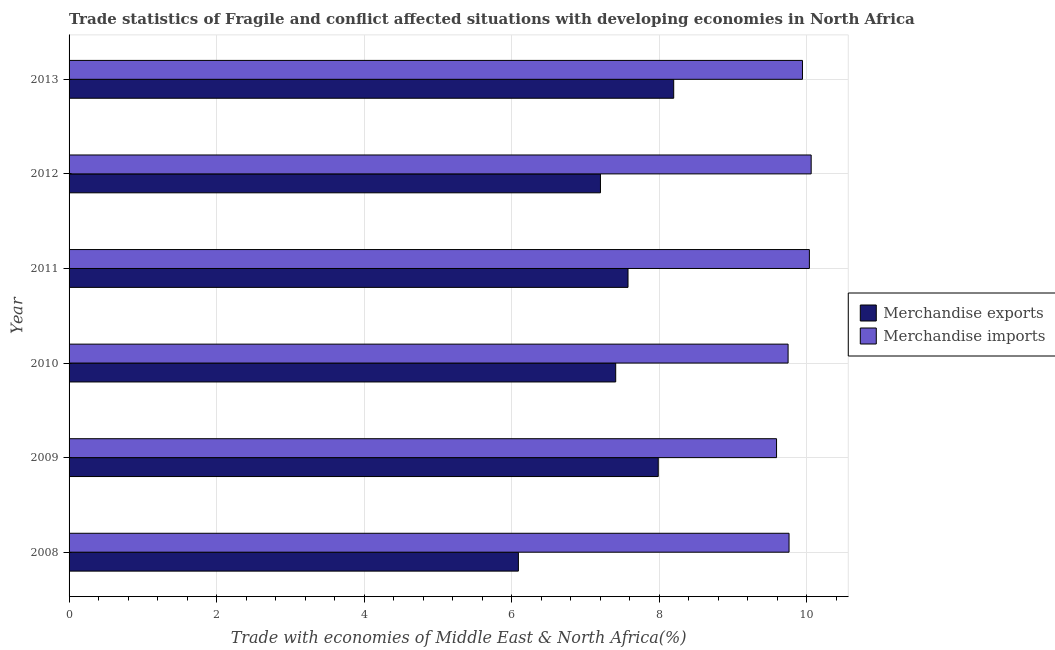How many different coloured bars are there?
Ensure brevity in your answer.  2. How many groups of bars are there?
Provide a succinct answer. 6. Are the number of bars per tick equal to the number of legend labels?
Give a very brief answer. Yes. How many bars are there on the 5th tick from the bottom?
Provide a succinct answer. 2. What is the label of the 2nd group of bars from the top?
Your answer should be very brief. 2012. In how many cases, is the number of bars for a given year not equal to the number of legend labels?
Your answer should be compact. 0. What is the merchandise imports in 2011?
Your answer should be very brief. 10.04. Across all years, what is the maximum merchandise imports?
Your response must be concise. 10.06. Across all years, what is the minimum merchandise exports?
Provide a succinct answer. 6.09. In which year was the merchandise imports maximum?
Provide a succinct answer. 2012. What is the total merchandise imports in the graph?
Give a very brief answer. 59.15. What is the difference between the merchandise imports in 2008 and that in 2011?
Offer a terse response. -0.28. What is the difference between the merchandise imports in 2009 and the merchandise exports in 2013?
Ensure brevity in your answer.  1.39. What is the average merchandise exports per year?
Your answer should be very brief. 7.41. In the year 2009, what is the difference between the merchandise imports and merchandise exports?
Ensure brevity in your answer.  1.6. What is the ratio of the merchandise exports in 2009 to that in 2012?
Offer a very short reply. 1.11. Is the merchandise exports in 2008 less than that in 2009?
Keep it short and to the point. Yes. Is the difference between the merchandise exports in 2008 and 2012 greater than the difference between the merchandise imports in 2008 and 2012?
Your response must be concise. No. What is the difference between the highest and the second highest merchandise imports?
Your response must be concise. 0.02. What is the difference between the highest and the lowest merchandise imports?
Give a very brief answer. 0.47. What does the 2nd bar from the top in 2008 represents?
Ensure brevity in your answer.  Merchandise exports. What does the 2nd bar from the bottom in 2012 represents?
Give a very brief answer. Merchandise imports. Are all the bars in the graph horizontal?
Make the answer very short. Yes. How many years are there in the graph?
Keep it short and to the point. 6. What is the difference between two consecutive major ticks on the X-axis?
Keep it short and to the point. 2. Are the values on the major ticks of X-axis written in scientific E-notation?
Your answer should be compact. No. Does the graph contain any zero values?
Give a very brief answer. No. Does the graph contain grids?
Ensure brevity in your answer.  Yes. How many legend labels are there?
Provide a succinct answer. 2. What is the title of the graph?
Your answer should be very brief. Trade statistics of Fragile and conflict affected situations with developing economies in North Africa. What is the label or title of the X-axis?
Ensure brevity in your answer.  Trade with economies of Middle East & North Africa(%). What is the Trade with economies of Middle East & North Africa(%) in Merchandise exports in 2008?
Give a very brief answer. 6.09. What is the Trade with economies of Middle East & North Africa(%) of Merchandise imports in 2008?
Your answer should be compact. 9.76. What is the Trade with economies of Middle East & North Africa(%) of Merchandise exports in 2009?
Offer a terse response. 7.99. What is the Trade with economies of Middle East & North Africa(%) in Merchandise imports in 2009?
Provide a short and direct response. 9.59. What is the Trade with economies of Middle East & North Africa(%) in Merchandise exports in 2010?
Keep it short and to the point. 7.41. What is the Trade with economies of Middle East & North Africa(%) in Merchandise imports in 2010?
Provide a short and direct response. 9.75. What is the Trade with economies of Middle East & North Africa(%) of Merchandise exports in 2011?
Provide a short and direct response. 7.58. What is the Trade with economies of Middle East & North Africa(%) of Merchandise imports in 2011?
Your response must be concise. 10.04. What is the Trade with economies of Middle East & North Africa(%) in Merchandise exports in 2012?
Make the answer very short. 7.21. What is the Trade with economies of Middle East & North Africa(%) of Merchandise imports in 2012?
Provide a succinct answer. 10.06. What is the Trade with economies of Middle East & North Africa(%) of Merchandise exports in 2013?
Provide a succinct answer. 8.2. What is the Trade with economies of Middle East & North Africa(%) in Merchandise imports in 2013?
Keep it short and to the point. 9.95. Across all years, what is the maximum Trade with economies of Middle East & North Africa(%) in Merchandise exports?
Provide a short and direct response. 8.2. Across all years, what is the maximum Trade with economies of Middle East & North Africa(%) in Merchandise imports?
Your answer should be very brief. 10.06. Across all years, what is the minimum Trade with economies of Middle East & North Africa(%) in Merchandise exports?
Offer a very short reply. 6.09. Across all years, what is the minimum Trade with economies of Middle East & North Africa(%) in Merchandise imports?
Ensure brevity in your answer.  9.59. What is the total Trade with economies of Middle East & North Africa(%) in Merchandise exports in the graph?
Offer a terse response. 44.48. What is the total Trade with economies of Middle East & North Africa(%) of Merchandise imports in the graph?
Offer a very short reply. 59.15. What is the difference between the Trade with economies of Middle East & North Africa(%) of Merchandise exports in 2008 and that in 2009?
Offer a terse response. -1.9. What is the difference between the Trade with economies of Middle East & North Africa(%) in Merchandise imports in 2008 and that in 2009?
Provide a short and direct response. 0.17. What is the difference between the Trade with economies of Middle East & North Africa(%) in Merchandise exports in 2008 and that in 2010?
Make the answer very short. -1.32. What is the difference between the Trade with economies of Middle East & North Africa(%) of Merchandise imports in 2008 and that in 2010?
Offer a very short reply. 0.01. What is the difference between the Trade with economies of Middle East & North Africa(%) in Merchandise exports in 2008 and that in 2011?
Your response must be concise. -1.49. What is the difference between the Trade with economies of Middle East & North Africa(%) in Merchandise imports in 2008 and that in 2011?
Offer a terse response. -0.28. What is the difference between the Trade with economies of Middle East & North Africa(%) of Merchandise exports in 2008 and that in 2012?
Give a very brief answer. -1.11. What is the difference between the Trade with economies of Middle East & North Africa(%) of Merchandise exports in 2008 and that in 2013?
Make the answer very short. -2.11. What is the difference between the Trade with economies of Middle East & North Africa(%) of Merchandise imports in 2008 and that in 2013?
Offer a terse response. -0.18. What is the difference between the Trade with economies of Middle East & North Africa(%) of Merchandise exports in 2009 and that in 2010?
Keep it short and to the point. 0.58. What is the difference between the Trade with economies of Middle East & North Africa(%) in Merchandise imports in 2009 and that in 2010?
Keep it short and to the point. -0.16. What is the difference between the Trade with economies of Middle East & North Africa(%) in Merchandise exports in 2009 and that in 2011?
Ensure brevity in your answer.  0.41. What is the difference between the Trade with economies of Middle East & North Africa(%) of Merchandise imports in 2009 and that in 2011?
Offer a terse response. -0.45. What is the difference between the Trade with economies of Middle East & North Africa(%) in Merchandise exports in 2009 and that in 2012?
Offer a terse response. 0.78. What is the difference between the Trade with economies of Middle East & North Africa(%) in Merchandise imports in 2009 and that in 2012?
Your response must be concise. -0.47. What is the difference between the Trade with economies of Middle East & North Africa(%) in Merchandise exports in 2009 and that in 2013?
Offer a very short reply. -0.21. What is the difference between the Trade with economies of Middle East & North Africa(%) of Merchandise imports in 2009 and that in 2013?
Your response must be concise. -0.35. What is the difference between the Trade with economies of Middle East & North Africa(%) of Merchandise exports in 2010 and that in 2011?
Ensure brevity in your answer.  -0.17. What is the difference between the Trade with economies of Middle East & North Africa(%) of Merchandise imports in 2010 and that in 2011?
Your answer should be compact. -0.29. What is the difference between the Trade with economies of Middle East & North Africa(%) of Merchandise exports in 2010 and that in 2012?
Give a very brief answer. 0.21. What is the difference between the Trade with economies of Middle East & North Africa(%) of Merchandise imports in 2010 and that in 2012?
Ensure brevity in your answer.  -0.31. What is the difference between the Trade with economies of Middle East & North Africa(%) of Merchandise exports in 2010 and that in 2013?
Your answer should be very brief. -0.79. What is the difference between the Trade with economies of Middle East & North Africa(%) in Merchandise imports in 2010 and that in 2013?
Keep it short and to the point. -0.2. What is the difference between the Trade with economies of Middle East & North Africa(%) of Merchandise exports in 2011 and that in 2012?
Your response must be concise. 0.37. What is the difference between the Trade with economies of Middle East & North Africa(%) in Merchandise imports in 2011 and that in 2012?
Make the answer very short. -0.02. What is the difference between the Trade with economies of Middle East & North Africa(%) in Merchandise exports in 2011 and that in 2013?
Your answer should be very brief. -0.62. What is the difference between the Trade with economies of Middle East & North Africa(%) in Merchandise imports in 2011 and that in 2013?
Give a very brief answer. 0.09. What is the difference between the Trade with economies of Middle East & North Africa(%) of Merchandise exports in 2012 and that in 2013?
Make the answer very short. -0.99. What is the difference between the Trade with economies of Middle East & North Africa(%) of Merchandise imports in 2012 and that in 2013?
Give a very brief answer. 0.12. What is the difference between the Trade with economies of Middle East & North Africa(%) in Merchandise exports in 2008 and the Trade with economies of Middle East & North Africa(%) in Merchandise imports in 2009?
Make the answer very short. -3.5. What is the difference between the Trade with economies of Middle East & North Africa(%) of Merchandise exports in 2008 and the Trade with economies of Middle East & North Africa(%) of Merchandise imports in 2010?
Your answer should be very brief. -3.66. What is the difference between the Trade with economies of Middle East & North Africa(%) of Merchandise exports in 2008 and the Trade with economies of Middle East & North Africa(%) of Merchandise imports in 2011?
Provide a short and direct response. -3.95. What is the difference between the Trade with economies of Middle East & North Africa(%) of Merchandise exports in 2008 and the Trade with economies of Middle East & North Africa(%) of Merchandise imports in 2012?
Ensure brevity in your answer.  -3.97. What is the difference between the Trade with economies of Middle East & North Africa(%) in Merchandise exports in 2008 and the Trade with economies of Middle East & North Africa(%) in Merchandise imports in 2013?
Your response must be concise. -3.85. What is the difference between the Trade with economies of Middle East & North Africa(%) in Merchandise exports in 2009 and the Trade with economies of Middle East & North Africa(%) in Merchandise imports in 2010?
Offer a terse response. -1.76. What is the difference between the Trade with economies of Middle East & North Africa(%) of Merchandise exports in 2009 and the Trade with economies of Middle East & North Africa(%) of Merchandise imports in 2011?
Give a very brief answer. -2.05. What is the difference between the Trade with economies of Middle East & North Africa(%) of Merchandise exports in 2009 and the Trade with economies of Middle East & North Africa(%) of Merchandise imports in 2012?
Give a very brief answer. -2.07. What is the difference between the Trade with economies of Middle East & North Africa(%) in Merchandise exports in 2009 and the Trade with economies of Middle East & North Africa(%) in Merchandise imports in 2013?
Offer a terse response. -1.96. What is the difference between the Trade with economies of Middle East & North Africa(%) of Merchandise exports in 2010 and the Trade with economies of Middle East & North Africa(%) of Merchandise imports in 2011?
Provide a succinct answer. -2.63. What is the difference between the Trade with economies of Middle East & North Africa(%) of Merchandise exports in 2010 and the Trade with economies of Middle East & North Africa(%) of Merchandise imports in 2012?
Offer a terse response. -2.65. What is the difference between the Trade with economies of Middle East & North Africa(%) of Merchandise exports in 2010 and the Trade with economies of Middle East & North Africa(%) of Merchandise imports in 2013?
Offer a terse response. -2.53. What is the difference between the Trade with economies of Middle East & North Africa(%) of Merchandise exports in 2011 and the Trade with economies of Middle East & North Africa(%) of Merchandise imports in 2012?
Make the answer very short. -2.48. What is the difference between the Trade with economies of Middle East & North Africa(%) in Merchandise exports in 2011 and the Trade with economies of Middle East & North Africa(%) in Merchandise imports in 2013?
Ensure brevity in your answer.  -2.37. What is the difference between the Trade with economies of Middle East & North Africa(%) of Merchandise exports in 2012 and the Trade with economies of Middle East & North Africa(%) of Merchandise imports in 2013?
Offer a very short reply. -2.74. What is the average Trade with economies of Middle East & North Africa(%) of Merchandise exports per year?
Keep it short and to the point. 7.41. What is the average Trade with economies of Middle East & North Africa(%) in Merchandise imports per year?
Provide a short and direct response. 9.86. In the year 2008, what is the difference between the Trade with economies of Middle East & North Africa(%) of Merchandise exports and Trade with economies of Middle East & North Africa(%) of Merchandise imports?
Provide a succinct answer. -3.67. In the year 2009, what is the difference between the Trade with economies of Middle East & North Africa(%) in Merchandise exports and Trade with economies of Middle East & North Africa(%) in Merchandise imports?
Ensure brevity in your answer.  -1.6. In the year 2010, what is the difference between the Trade with economies of Middle East & North Africa(%) in Merchandise exports and Trade with economies of Middle East & North Africa(%) in Merchandise imports?
Give a very brief answer. -2.34. In the year 2011, what is the difference between the Trade with economies of Middle East & North Africa(%) in Merchandise exports and Trade with economies of Middle East & North Africa(%) in Merchandise imports?
Your answer should be compact. -2.46. In the year 2012, what is the difference between the Trade with economies of Middle East & North Africa(%) of Merchandise exports and Trade with economies of Middle East & North Africa(%) of Merchandise imports?
Provide a short and direct response. -2.86. In the year 2013, what is the difference between the Trade with economies of Middle East & North Africa(%) in Merchandise exports and Trade with economies of Middle East & North Africa(%) in Merchandise imports?
Keep it short and to the point. -1.75. What is the ratio of the Trade with economies of Middle East & North Africa(%) of Merchandise exports in 2008 to that in 2009?
Provide a short and direct response. 0.76. What is the ratio of the Trade with economies of Middle East & North Africa(%) in Merchandise imports in 2008 to that in 2009?
Your response must be concise. 1.02. What is the ratio of the Trade with economies of Middle East & North Africa(%) in Merchandise exports in 2008 to that in 2010?
Give a very brief answer. 0.82. What is the ratio of the Trade with economies of Middle East & North Africa(%) of Merchandise exports in 2008 to that in 2011?
Your answer should be very brief. 0.8. What is the ratio of the Trade with economies of Middle East & North Africa(%) in Merchandise imports in 2008 to that in 2011?
Ensure brevity in your answer.  0.97. What is the ratio of the Trade with economies of Middle East & North Africa(%) of Merchandise exports in 2008 to that in 2012?
Provide a short and direct response. 0.85. What is the ratio of the Trade with economies of Middle East & North Africa(%) of Merchandise imports in 2008 to that in 2012?
Give a very brief answer. 0.97. What is the ratio of the Trade with economies of Middle East & North Africa(%) of Merchandise exports in 2008 to that in 2013?
Make the answer very short. 0.74. What is the ratio of the Trade with economies of Middle East & North Africa(%) in Merchandise imports in 2008 to that in 2013?
Make the answer very short. 0.98. What is the ratio of the Trade with economies of Middle East & North Africa(%) of Merchandise exports in 2009 to that in 2010?
Provide a short and direct response. 1.08. What is the ratio of the Trade with economies of Middle East & North Africa(%) of Merchandise imports in 2009 to that in 2010?
Keep it short and to the point. 0.98. What is the ratio of the Trade with economies of Middle East & North Africa(%) in Merchandise exports in 2009 to that in 2011?
Your answer should be very brief. 1.05. What is the ratio of the Trade with economies of Middle East & North Africa(%) of Merchandise imports in 2009 to that in 2011?
Keep it short and to the point. 0.96. What is the ratio of the Trade with economies of Middle East & North Africa(%) of Merchandise exports in 2009 to that in 2012?
Your answer should be compact. 1.11. What is the ratio of the Trade with economies of Middle East & North Africa(%) of Merchandise imports in 2009 to that in 2012?
Your response must be concise. 0.95. What is the ratio of the Trade with economies of Middle East & North Africa(%) of Merchandise exports in 2009 to that in 2013?
Give a very brief answer. 0.97. What is the ratio of the Trade with economies of Middle East & North Africa(%) in Merchandise imports in 2009 to that in 2013?
Provide a short and direct response. 0.96. What is the ratio of the Trade with economies of Middle East & North Africa(%) of Merchandise exports in 2010 to that in 2011?
Your response must be concise. 0.98. What is the ratio of the Trade with economies of Middle East & North Africa(%) in Merchandise imports in 2010 to that in 2011?
Provide a short and direct response. 0.97. What is the ratio of the Trade with economies of Middle East & North Africa(%) in Merchandise exports in 2010 to that in 2012?
Your answer should be very brief. 1.03. What is the ratio of the Trade with economies of Middle East & North Africa(%) of Merchandise imports in 2010 to that in 2012?
Your response must be concise. 0.97. What is the ratio of the Trade with economies of Middle East & North Africa(%) in Merchandise exports in 2010 to that in 2013?
Provide a succinct answer. 0.9. What is the ratio of the Trade with economies of Middle East & North Africa(%) in Merchandise imports in 2010 to that in 2013?
Ensure brevity in your answer.  0.98. What is the ratio of the Trade with economies of Middle East & North Africa(%) in Merchandise exports in 2011 to that in 2012?
Your answer should be very brief. 1.05. What is the ratio of the Trade with economies of Middle East & North Africa(%) in Merchandise imports in 2011 to that in 2012?
Give a very brief answer. 1. What is the ratio of the Trade with economies of Middle East & North Africa(%) in Merchandise exports in 2011 to that in 2013?
Your answer should be very brief. 0.92. What is the ratio of the Trade with economies of Middle East & North Africa(%) in Merchandise imports in 2011 to that in 2013?
Give a very brief answer. 1.01. What is the ratio of the Trade with economies of Middle East & North Africa(%) in Merchandise exports in 2012 to that in 2013?
Provide a short and direct response. 0.88. What is the ratio of the Trade with economies of Middle East & North Africa(%) of Merchandise imports in 2012 to that in 2013?
Offer a terse response. 1.01. What is the difference between the highest and the second highest Trade with economies of Middle East & North Africa(%) of Merchandise exports?
Make the answer very short. 0.21. What is the difference between the highest and the second highest Trade with economies of Middle East & North Africa(%) in Merchandise imports?
Offer a terse response. 0.02. What is the difference between the highest and the lowest Trade with economies of Middle East & North Africa(%) of Merchandise exports?
Your response must be concise. 2.11. What is the difference between the highest and the lowest Trade with economies of Middle East & North Africa(%) in Merchandise imports?
Your response must be concise. 0.47. 